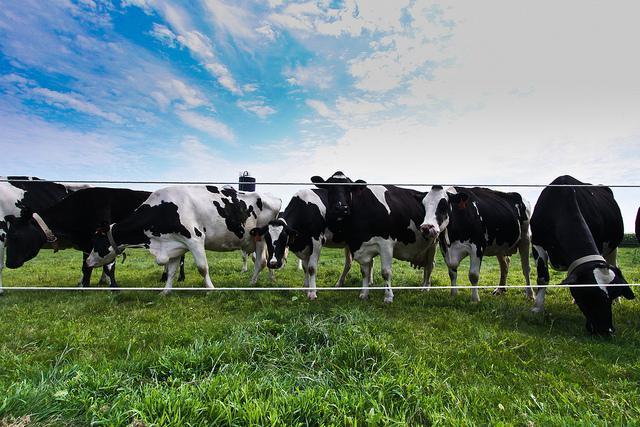How many cows are in the picture?
Give a very brief answer. 7. How many people are wearing orange shirts?
Give a very brief answer. 0. 